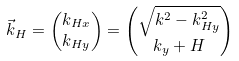<formula> <loc_0><loc_0><loc_500><loc_500>\vec { k } _ { H } & = \begin{pmatrix} { k _ { H x } } \\ { k _ { H y } } \end{pmatrix} = \begin{pmatrix} { \sqrt { k ^ { 2 } - k _ { H y } ^ { 2 } } } \\ { k _ { y } + H } \end{pmatrix}</formula> 